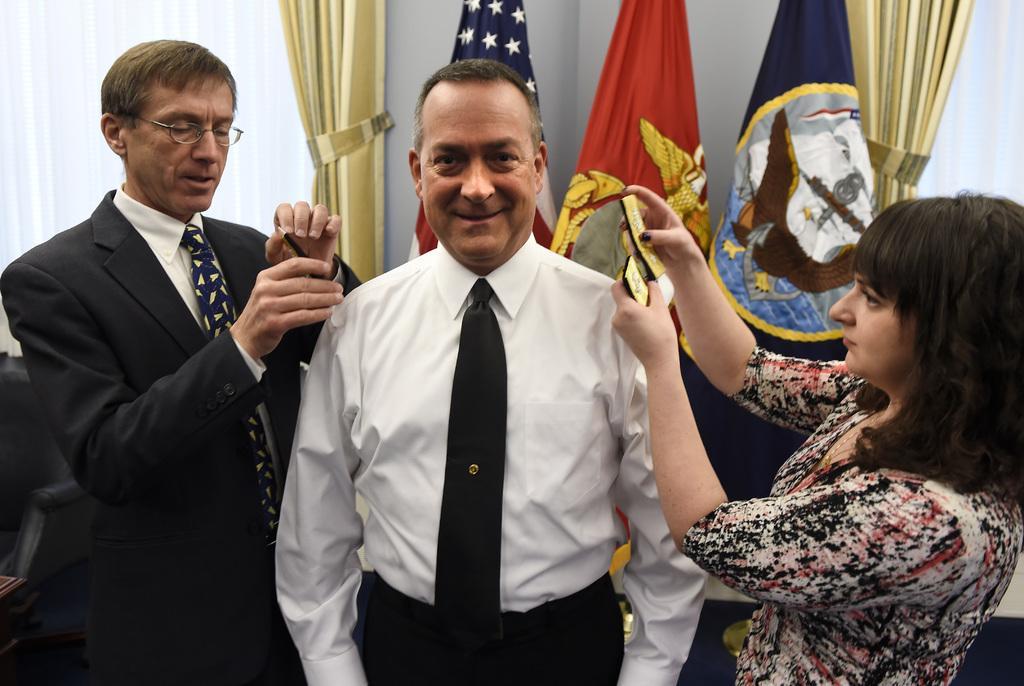In one or two sentences, can you explain what this image depicts? In the image we can see there are two men and a woman standing and they are wearing clothes. This is a tie and speculates, we can even see there are three flags, these are the curtains. 